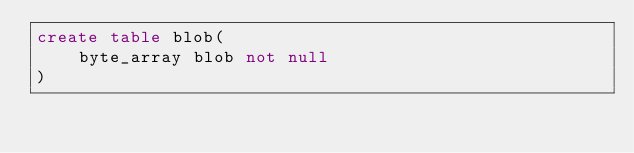Convert code to text. <code><loc_0><loc_0><loc_500><loc_500><_SQL_>create table blob(
    byte_array blob not null
)</code> 